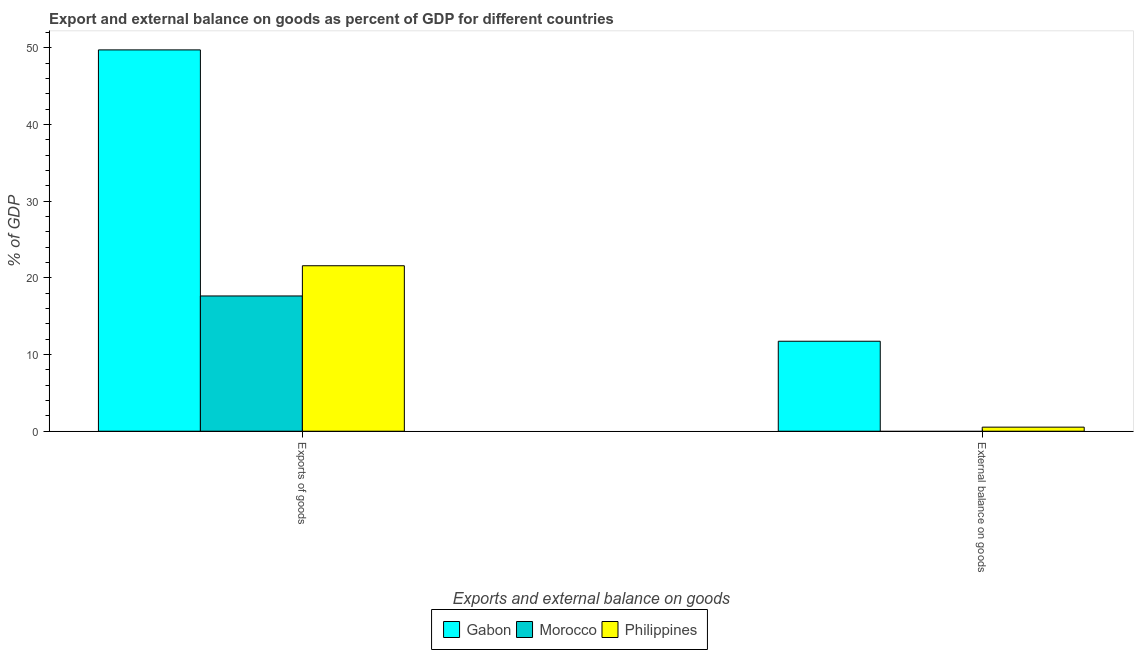How many different coloured bars are there?
Offer a terse response. 3. How many groups of bars are there?
Provide a short and direct response. 2. Are the number of bars per tick equal to the number of legend labels?
Offer a very short reply. No. How many bars are there on the 2nd tick from the left?
Offer a terse response. 2. How many bars are there on the 1st tick from the right?
Ensure brevity in your answer.  2. What is the label of the 2nd group of bars from the left?
Ensure brevity in your answer.  External balance on goods. What is the export of goods as percentage of gdp in Philippines?
Provide a short and direct response. 21.58. Across all countries, what is the maximum external balance on goods as percentage of gdp?
Keep it short and to the point. 11.73. In which country was the export of goods as percentage of gdp maximum?
Provide a short and direct response. Gabon. What is the total external balance on goods as percentage of gdp in the graph?
Your answer should be compact. 12.26. What is the difference between the export of goods as percentage of gdp in Philippines and that in Morocco?
Keep it short and to the point. 3.94. What is the difference between the external balance on goods as percentage of gdp in Gabon and the export of goods as percentage of gdp in Morocco?
Offer a terse response. -5.91. What is the average export of goods as percentage of gdp per country?
Offer a terse response. 29.64. What is the difference between the export of goods as percentage of gdp and external balance on goods as percentage of gdp in Philippines?
Ensure brevity in your answer.  21.04. In how many countries, is the external balance on goods as percentage of gdp greater than 46 %?
Provide a succinct answer. 0. Is the external balance on goods as percentage of gdp in Philippines less than that in Gabon?
Ensure brevity in your answer.  Yes. In how many countries, is the export of goods as percentage of gdp greater than the average export of goods as percentage of gdp taken over all countries?
Your answer should be compact. 1. How many bars are there?
Keep it short and to the point. 5. Are all the bars in the graph horizontal?
Your answer should be compact. No. How many countries are there in the graph?
Give a very brief answer. 3. What is the difference between two consecutive major ticks on the Y-axis?
Offer a terse response. 10. Does the graph contain any zero values?
Your answer should be compact. Yes. Does the graph contain grids?
Your response must be concise. No. How many legend labels are there?
Offer a terse response. 3. What is the title of the graph?
Offer a very short reply. Export and external balance on goods as percent of GDP for different countries. What is the label or title of the X-axis?
Make the answer very short. Exports and external balance on goods. What is the label or title of the Y-axis?
Ensure brevity in your answer.  % of GDP. What is the % of GDP of Gabon in Exports of goods?
Your answer should be compact. 49.72. What is the % of GDP of Morocco in Exports of goods?
Your response must be concise. 17.64. What is the % of GDP in Philippines in Exports of goods?
Provide a short and direct response. 21.58. What is the % of GDP of Gabon in External balance on goods?
Give a very brief answer. 11.73. What is the % of GDP in Morocco in External balance on goods?
Ensure brevity in your answer.  0. What is the % of GDP in Philippines in External balance on goods?
Your answer should be very brief. 0.53. Across all Exports and external balance on goods, what is the maximum % of GDP of Gabon?
Your response must be concise. 49.72. Across all Exports and external balance on goods, what is the maximum % of GDP in Morocco?
Your response must be concise. 17.64. Across all Exports and external balance on goods, what is the maximum % of GDP of Philippines?
Your response must be concise. 21.58. Across all Exports and external balance on goods, what is the minimum % of GDP of Gabon?
Provide a short and direct response. 11.73. Across all Exports and external balance on goods, what is the minimum % of GDP in Philippines?
Give a very brief answer. 0.53. What is the total % of GDP in Gabon in the graph?
Give a very brief answer. 61.45. What is the total % of GDP of Morocco in the graph?
Ensure brevity in your answer.  17.64. What is the total % of GDP of Philippines in the graph?
Your answer should be very brief. 22.11. What is the difference between the % of GDP in Gabon in Exports of goods and that in External balance on goods?
Your answer should be very brief. 37.99. What is the difference between the % of GDP in Philippines in Exports of goods and that in External balance on goods?
Give a very brief answer. 21.04. What is the difference between the % of GDP in Gabon in Exports of goods and the % of GDP in Philippines in External balance on goods?
Give a very brief answer. 49.19. What is the difference between the % of GDP in Morocco in Exports of goods and the % of GDP in Philippines in External balance on goods?
Keep it short and to the point. 17.11. What is the average % of GDP in Gabon per Exports and external balance on goods?
Provide a short and direct response. 30.73. What is the average % of GDP in Morocco per Exports and external balance on goods?
Offer a very short reply. 8.82. What is the average % of GDP of Philippines per Exports and external balance on goods?
Make the answer very short. 11.05. What is the difference between the % of GDP in Gabon and % of GDP in Morocco in Exports of goods?
Offer a very short reply. 32.08. What is the difference between the % of GDP of Gabon and % of GDP of Philippines in Exports of goods?
Your answer should be compact. 28.14. What is the difference between the % of GDP in Morocco and % of GDP in Philippines in Exports of goods?
Your answer should be very brief. -3.94. What is the difference between the % of GDP in Gabon and % of GDP in Philippines in External balance on goods?
Make the answer very short. 11.2. What is the ratio of the % of GDP of Gabon in Exports of goods to that in External balance on goods?
Your answer should be very brief. 4.24. What is the ratio of the % of GDP of Philippines in Exports of goods to that in External balance on goods?
Offer a terse response. 40.59. What is the difference between the highest and the second highest % of GDP in Gabon?
Your answer should be compact. 37.99. What is the difference between the highest and the second highest % of GDP of Philippines?
Offer a terse response. 21.04. What is the difference between the highest and the lowest % of GDP in Gabon?
Your response must be concise. 37.99. What is the difference between the highest and the lowest % of GDP in Morocco?
Your answer should be compact. 17.64. What is the difference between the highest and the lowest % of GDP of Philippines?
Your response must be concise. 21.04. 